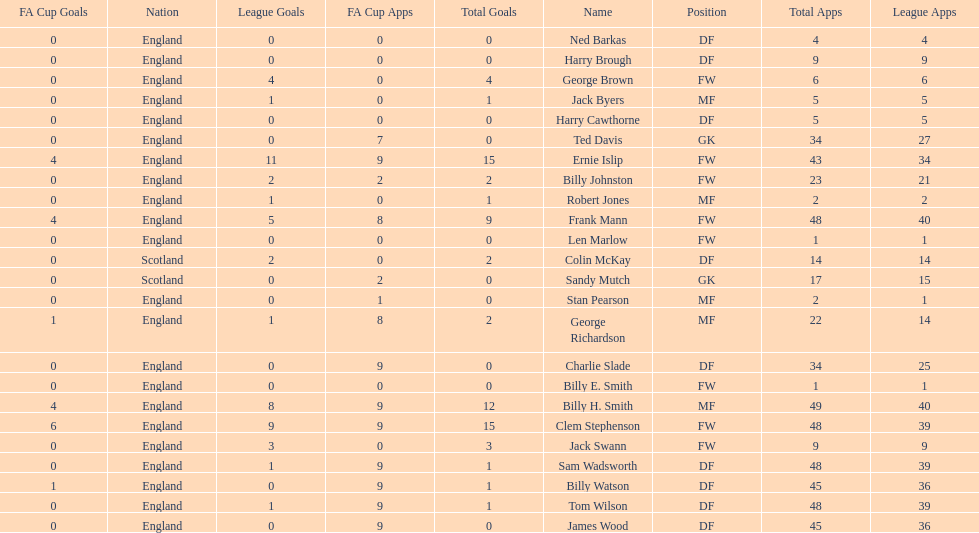Average number of goals scored by players from scotland 1. 